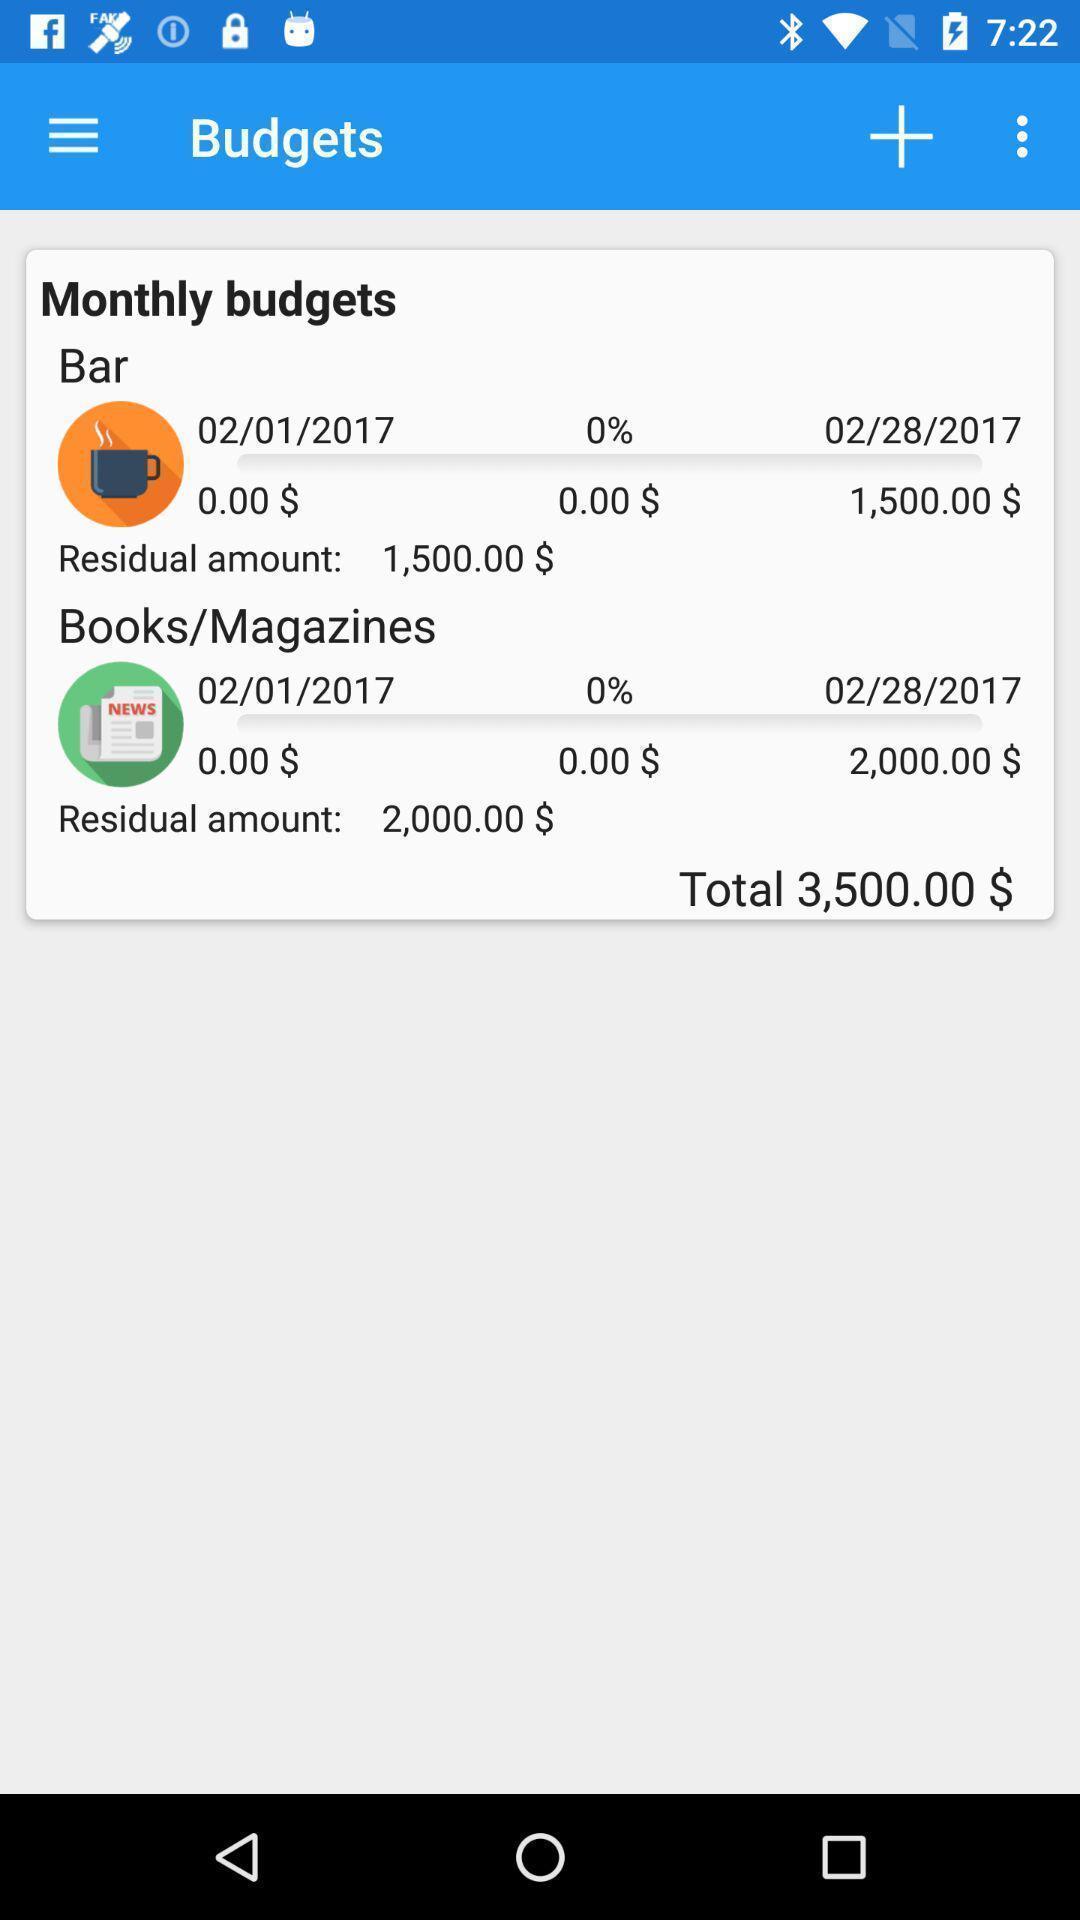Summarize the information in this screenshot. Screen displaying the budgets page. 